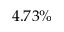Convert formula to latex. <formula><loc_0><loc_0><loc_500><loc_500>4 . 7 3 \%</formula> 